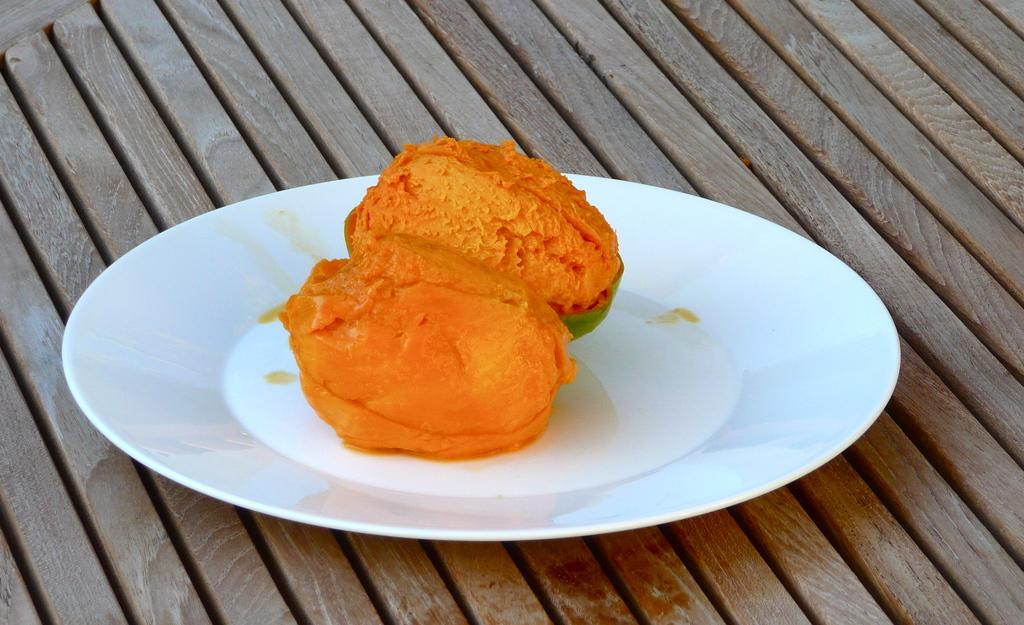What is on the plate that is visible in the image? The plate contains fruits in the image. Where is the plate located? The plate is placed on a table. What type of protest is happening in the image? There is no protest present in the image; it features a plate with fruits on a table. What type of canvas is visible in the image? There is no canvas present in the image. 